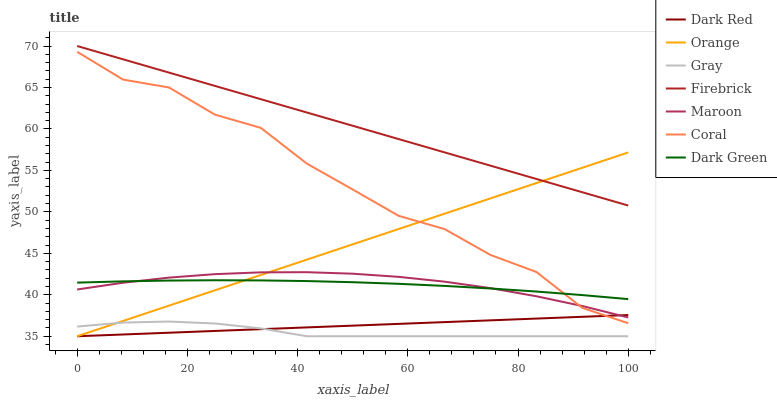Does Gray have the minimum area under the curve?
Answer yes or no. Yes. Does Firebrick have the maximum area under the curve?
Answer yes or no. Yes. Does Dark Red have the minimum area under the curve?
Answer yes or no. No. Does Dark Red have the maximum area under the curve?
Answer yes or no. No. Is Firebrick the smoothest?
Answer yes or no. Yes. Is Coral the roughest?
Answer yes or no. Yes. Is Dark Red the smoothest?
Answer yes or no. No. Is Dark Red the roughest?
Answer yes or no. No. Does Gray have the lowest value?
Answer yes or no. Yes. Does Firebrick have the lowest value?
Answer yes or no. No. Does Firebrick have the highest value?
Answer yes or no. Yes. Does Dark Red have the highest value?
Answer yes or no. No. Is Gray less than Firebrick?
Answer yes or no. Yes. Is Firebrick greater than Maroon?
Answer yes or no. Yes. Does Dark Red intersect Orange?
Answer yes or no. Yes. Is Dark Red less than Orange?
Answer yes or no. No. Is Dark Red greater than Orange?
Answer yes or no. No. Does Gray intersect Firebrick?
Answer yes or no. No. 